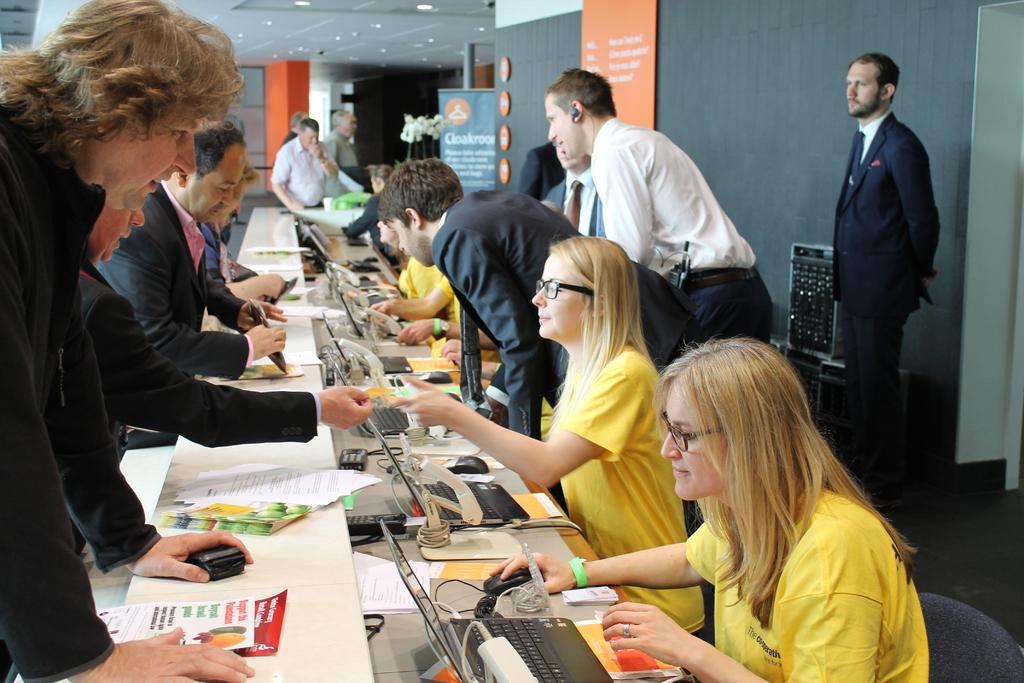What are the people sitting in front of in the image? The people are sitting in front of a table. What objects can be seen on the table? There are laptops and papers on the table. Are there any people standing in the image? Yes, there are people standing on the left side. What type of stew is being served on the table in the image? There is no stew present in the image; the table only contains laptops and papers. Can you tell me the name of the daughter of the person sitting on the right side? There is no information about a daughter or any personal details of the people in the image. 